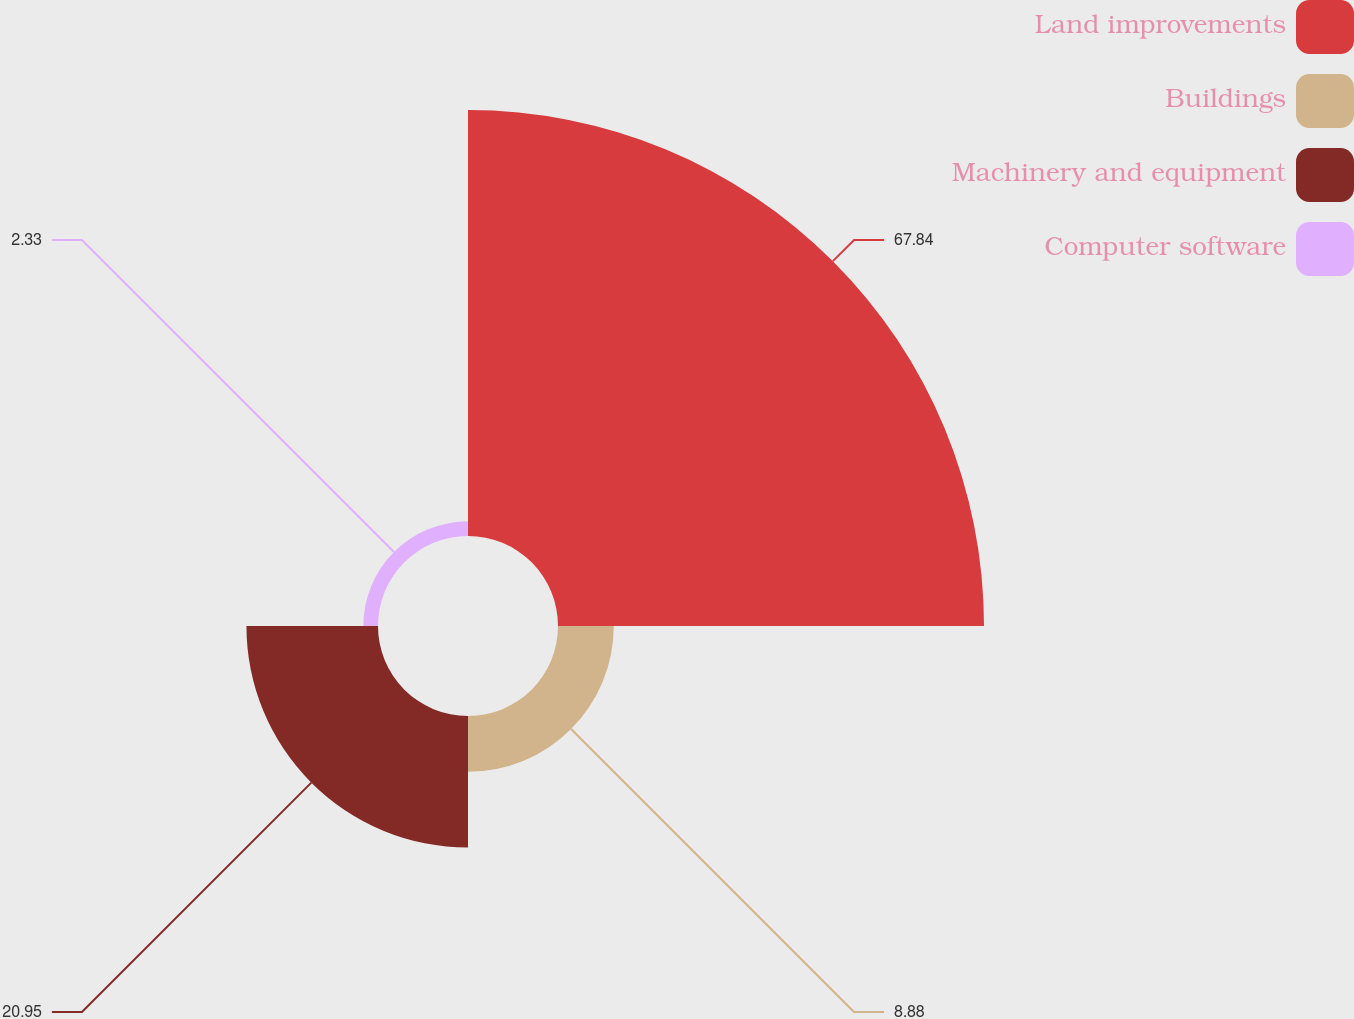Convert chart. <chart><loc_0><loc_0><loc_500><loc_500><pie_chart><fcel>Land improvements<fcel>Buildings<fcel>Machinery and equipment<fcel>Computer software<nl><fcel>67.84%<fcel>8.88%<fcel>20.95%<fcel>2.33%<nl></chart> 